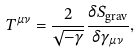<formula> <loc_0><loc_0><loc_500><loc_500>T ^ { \mu \nu } = \frac { 2 } { \sqrt { - \gamma } } \frac { \delta S _ { \text {grav} } } { \delta \gamma _ { \mu \nu } } ,</formula> 